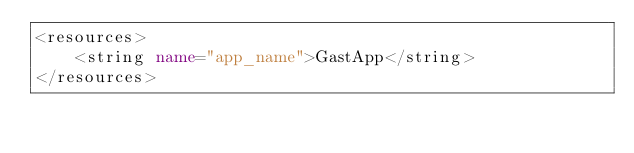Convert code to text. <code><loc_0><loc_0><loc_500><loc_500><_XML_><resources>
    <string name="app_name">GastApp</string>
</resources></code> 